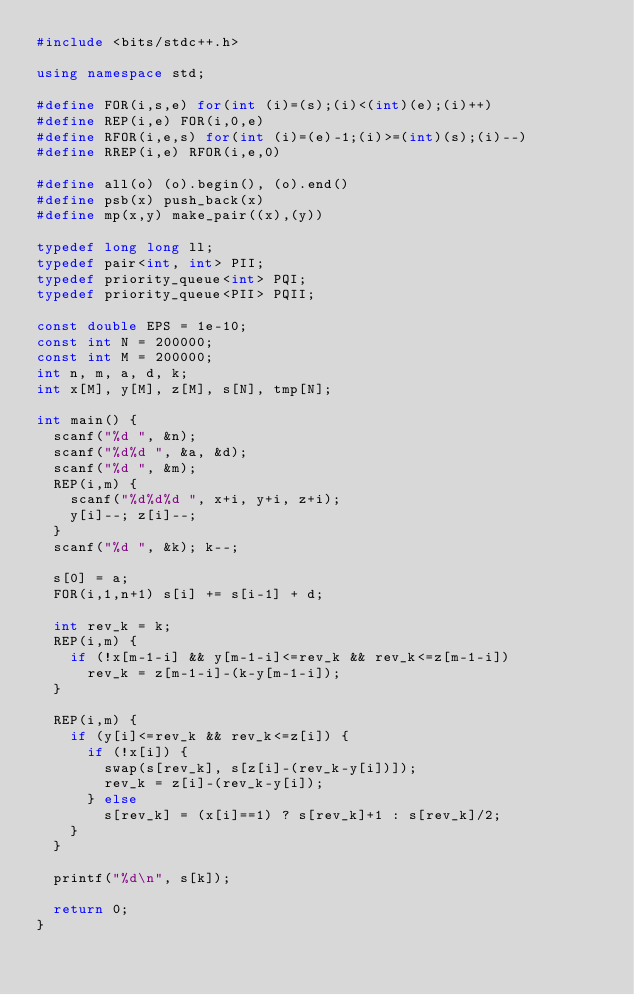<code> <loc_0><loc_0><loc_500><loc_500><_C++_>#include <bits/stdc++.h>

using namespace std;

#define FOR(i,s,e) for(int (i)=(s);(i)<(int)(e);(i)++)
#define REP(i,e) FOR(i,0,e)
#define RFOR(i,e,s) for(int (i)=(e)-1;(i)>=(int)(s);(i)--)
#define RREP(i,e) RFOR(i,e,0)

#define all(o) (o).begin(), (o).end()
#define psb(x) push_back(x)
#define mp(x,y) make_pair((x),(y))

typedef long long ll;
typedef pair<int, int> PII;
typedef priority_queue<int> PQI;
typedef priority_queue<PII> PQII;

const double EPS = 1e-10;
const int N = 200000;
const int M = 200000;
int n, m, a, d, k;
int x[M], y[M], z[M], s[N], tmp[N];

int main() {
  scanf("%d ", &n);
  scanf("%d%d ", &a, &d);
  scanf("%d ", &m);
  REP(i,m) {
    scanf("%d%d%d ", x+i, y+i, z+i);
    y[i]--; z[i]--;
  }
  scanf("%d ", &k); k--;

  s[0] = a;
  FOR(i,1,n+1) s[i] += s[i-1] + d;
  
  int rev_k = k;
  REP(i,m) {
    if (!x[m-1-i] && y[m-1-i]<=rev_k && rev_k<=z[m-1-i])
      rev_k = z[m-1-i]-(k-y[m-1-i]);
  }

  REP(i,m) {
    if (y[i]<=rev_k && rev_k<=z[i]) {
      if (!x[i]) {
        swap(s[rev_k], s[z[i]-(rev_k-y[i])]); 
        rev_k = z[i]-(rev_k-y[i]); 
      } else
        s[rev_k] = (x[i]==1) ? s[rev_k]+1 : s[rev_k]/2;
    }
  }

  printf("%d\n", s[k]);

  return 0;
}</code> 